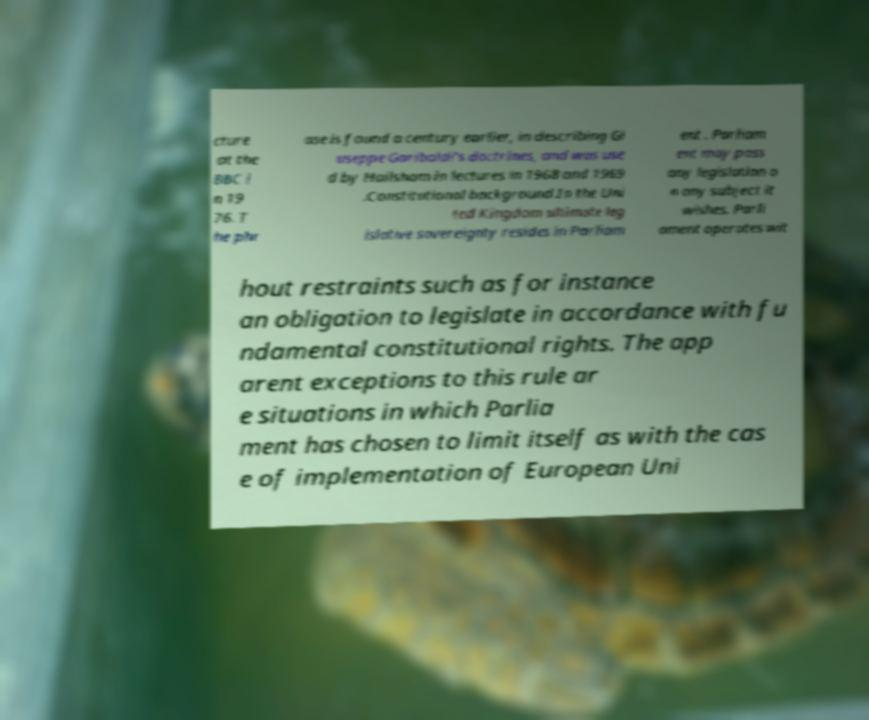Please read and relay the text visible in this image. What does it say? cture at the BBC i n 19 76. T he phr ase is found a century earlier, in describing Gi useppe Garibaldi's doctrines, and was use d by Hailsham in lectures in 1968 and 1969 .Constitutional background.In the Uni ted Kingdom ultimate leg islative sovereignty resides in Parliam ent . Parliam ent may pass any legislation o n any subject it wishes. Parli ament operates wit hout restraints such as for instance an obligation to legislate in accordance with fu ndamental constitutional rights. The app arent exceptions to this rule ar e situations in which Parlia ment has chosen to limit itself as with the cas e of implementation of European Uni 